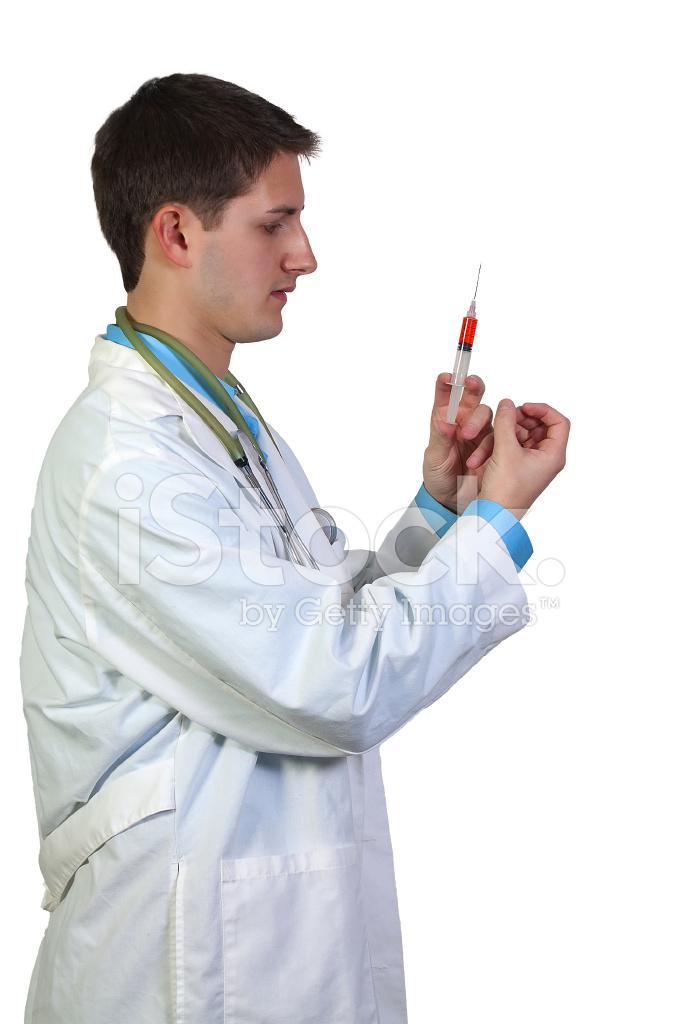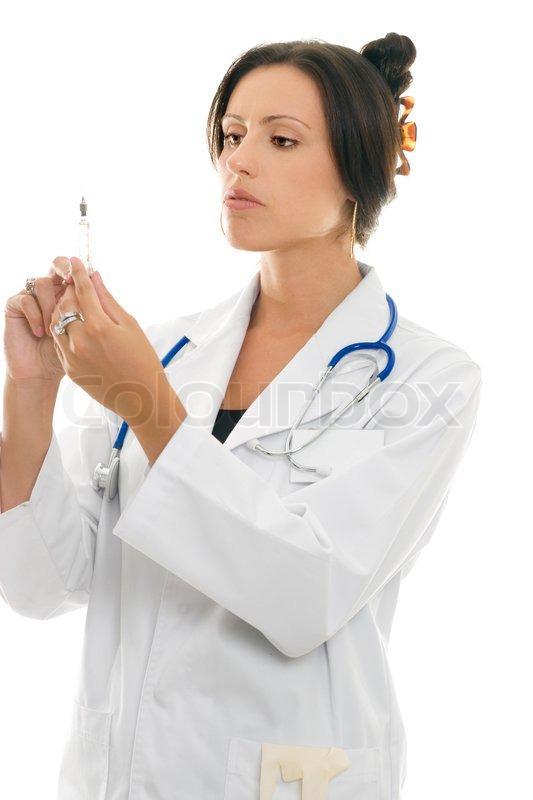The first image is the image on the left, the second image is the image on the right. For the images displayed, is the sentence "There is a woman visible in one of the images." factually correct? Answer yes or no. Yes. The first image is the image on the left, the second image is the image on the right. Analyze the images presented: Is the assertion "Two doctors are looking at syringes." valid? Answer yes or no. Yes. 